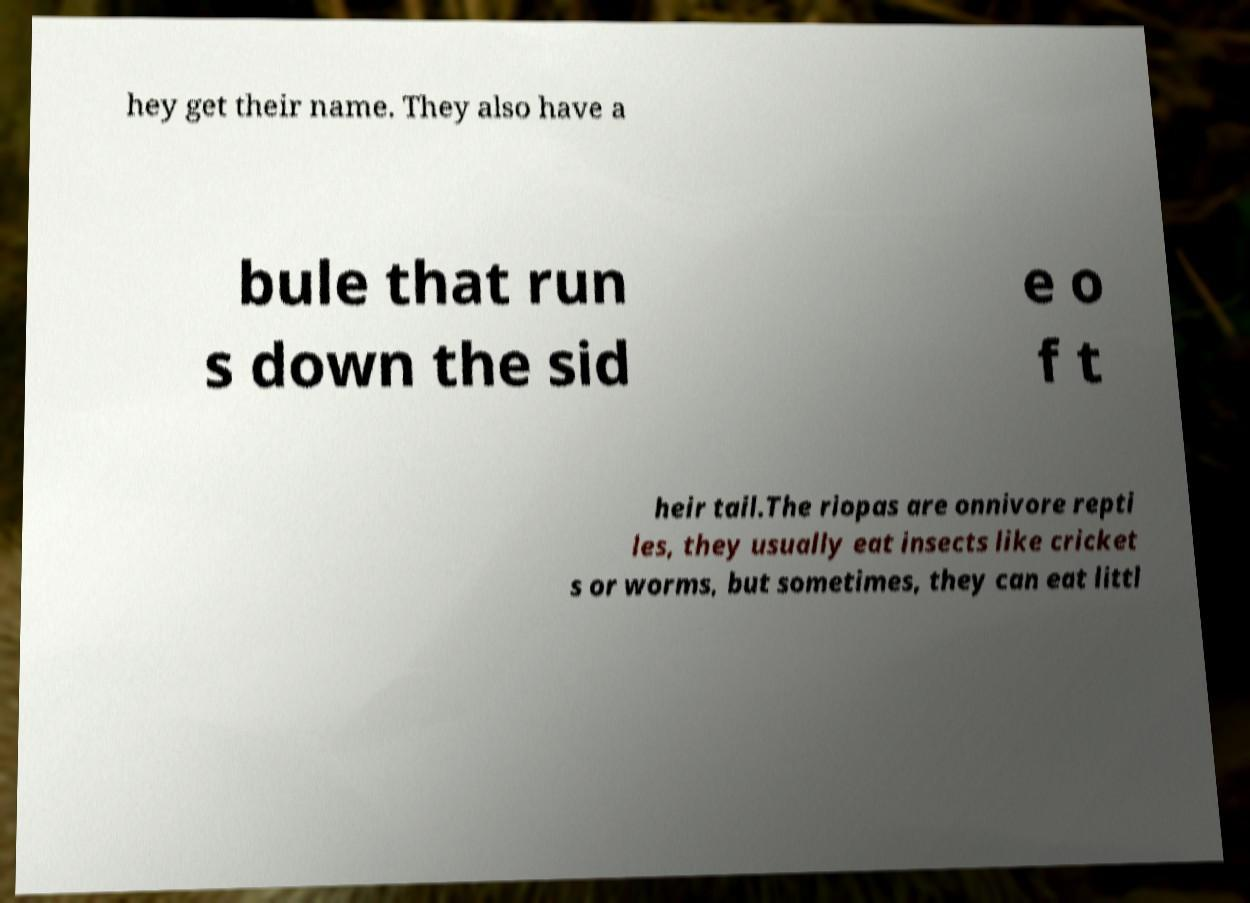Please identify and transcribe the text found in this image. hey get their name. They also have a bule that run s down the sid e o f t heir tail.The riopas are onnivore repti les, they usually eat insects like cricket s or worms, but sometimes, they can eat littl 